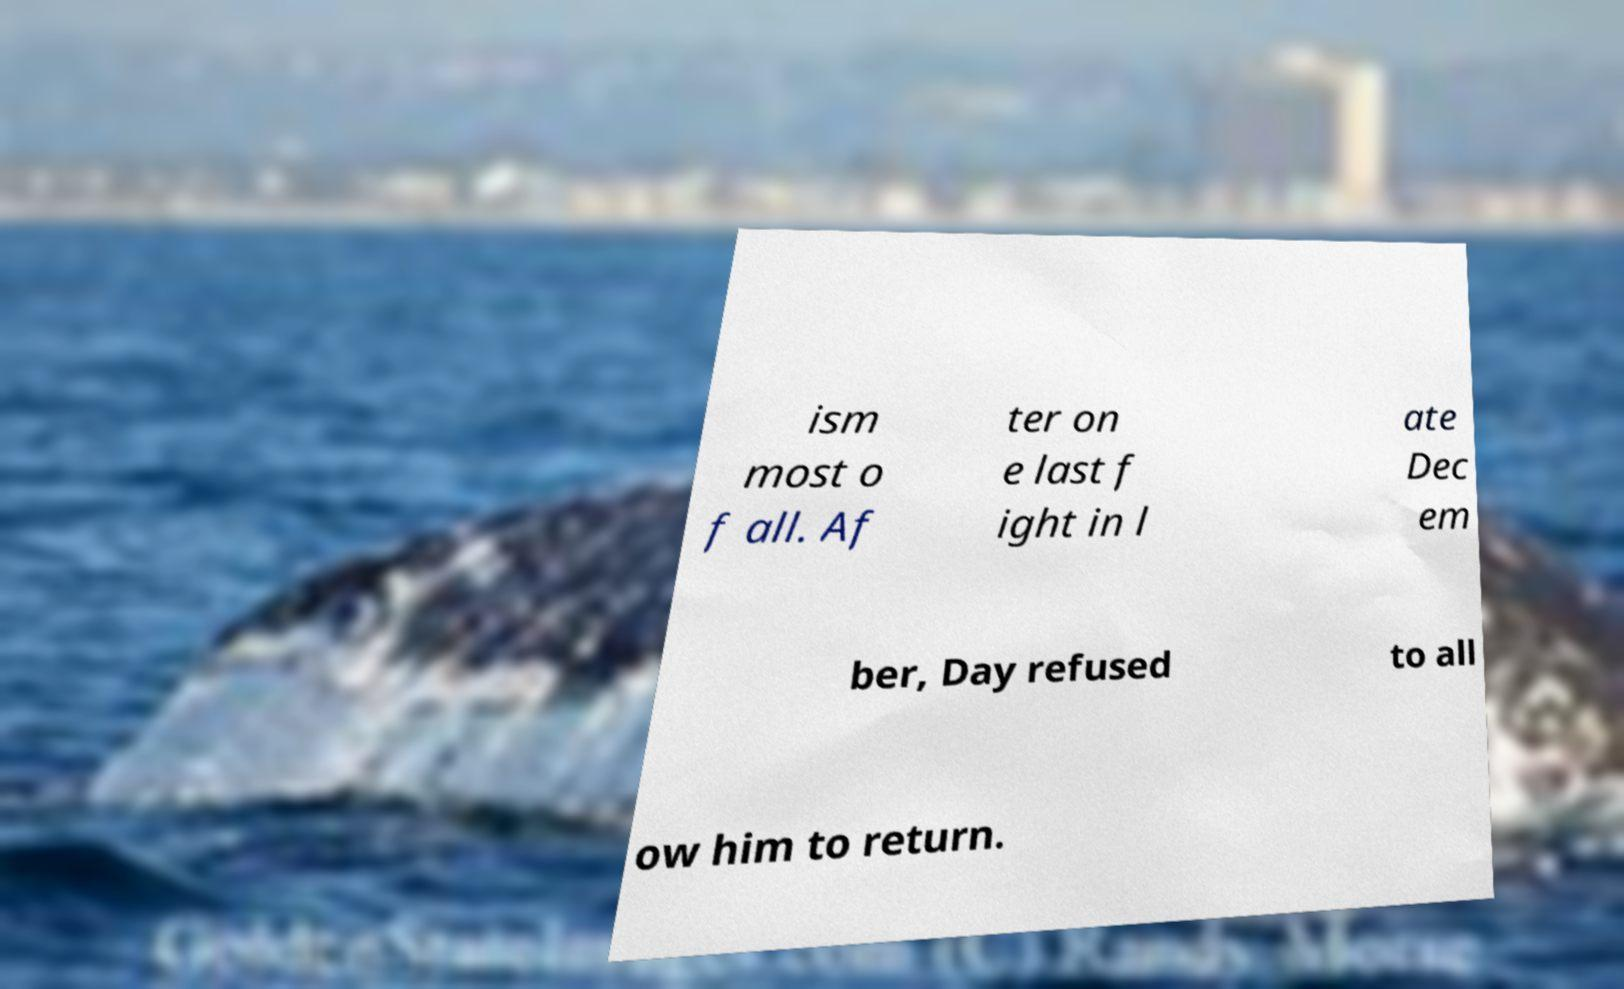I need the written content from this picture converted into text. Can you do that? ism most o f all. Af ter on e last f ight in l ate Dec em ber, Day refused to all ow him to return. 